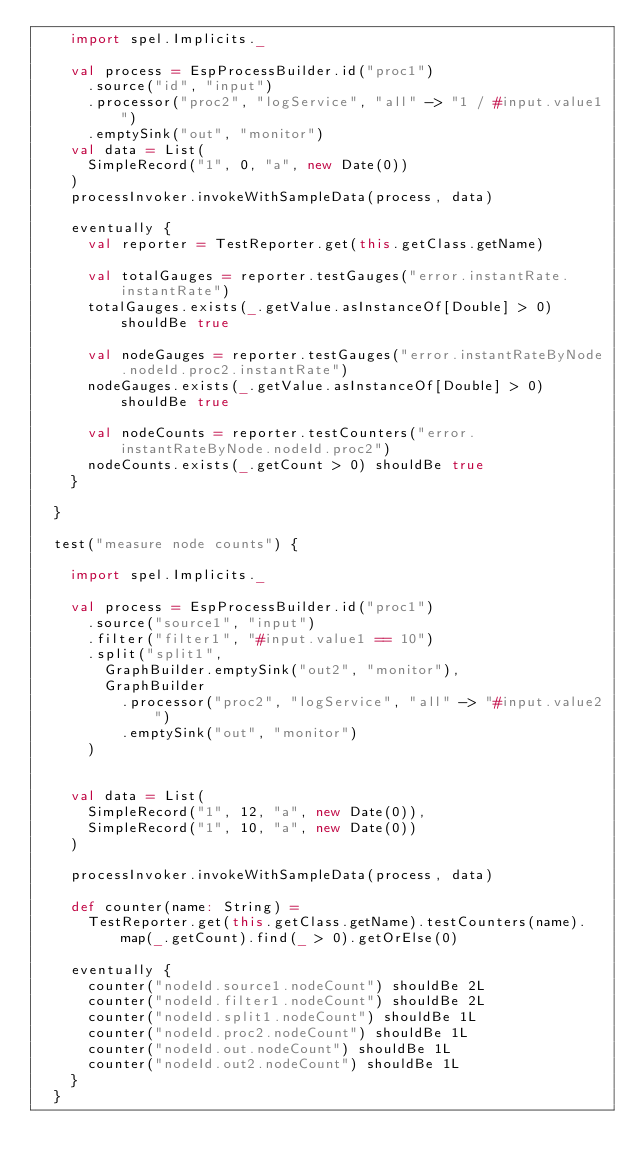Convert code to text. <code><loc_0><loc_0><loc_500><loc_500><_Scala_>    import spel.Implicits._

    val process = EspProcessBuilder.id("proc1")
      .source("id", "input")
      .processor("proc2", "logService", "all" -> "1 / #input.value1")
      .emptySink("out", "monitor")
    val data = List(
      SimpleRecord("1", 0, "a", new Date(0))
    )
    processInvoker.invokeWithSampleData(process, data)

    eventually {
      val reporter = TestReporter.get(this.getClass.getName)

      val totalGauges = reporter.testGauges("error.instantRate.instantRate")
      totalGauges.exists(_.getValue.asInstanceOf[Double] > 0) shouldBe true

      val nodeGauges = reporter.testGauges("error.instantRateByNode.nodeId.proc2.instantRate")
      nodeGauges.exists(_.getValue.asInstanceOf[Double] > 0) shouldBe true

      val nodeCounts = reporter.testCounters("error.instantRateByNode.nodeId.proc2")
      nodeCounts.exists(_.getCount > 0) shouldBe true
    }

  }

  test("measure node counts") {

    import spel.Implicits._

    val process = EspProcessBuilder.id("proc1")
      .source("source1", "input")
      .filter("filter1", "#input.value1 == 10")
      .split("split1",
        GraphBuilder.emptySink("out2", "monitor"),
        GraphBuilder
          .processor("proc2", "logService", "all" -> "#input.value2")
          .emptySink("out", "monitor")
      )


    val data = List(
      SimpleRecord("1", 12, "a", new Date(0)),
      SimpleRecord("1", 10, "a", new Date(0))
    )

    processInvoker.invokeWithSampleData(process, data)

    def counter(name: String) =
      TestReporter.get(this.getClass.getName).testCounters(name).map(_.getCount).find(_ > 0).getOrElse(0)

    eventually {
      counter("nodeId.source1.nodeCount") shouldBe 2L
      counter("nodeId.filter1.nodeCount") shouldBe 2L
      counter("nodeId.split1.nodeCount") shouldBe 1L
      counter("nodeId.proc2.nodeCount") shouldBe 1L
      counter("nodeId.out.nodeCount") shouldBe 1L
      counter("nodeId.out2.nodeCount") shouldBe 1L
    }
  }
</code> 